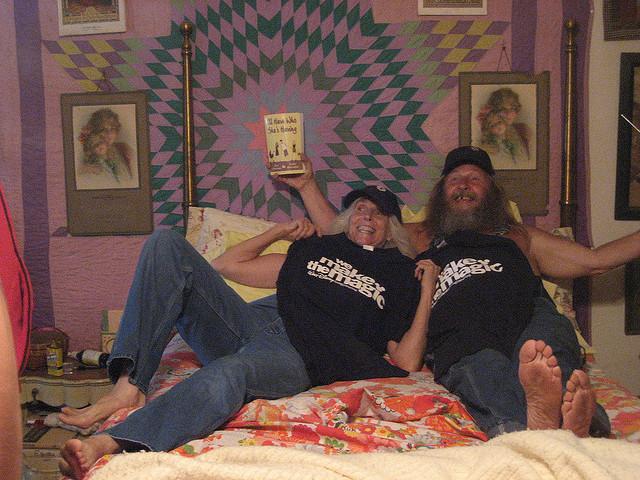What are these people sitting on?
Answer briefly. Bed. Are the people wearing shoes?
Quick response, please. No. What type of quilt is hanging behind the bed?
Be succinct. Circular diamonds. 